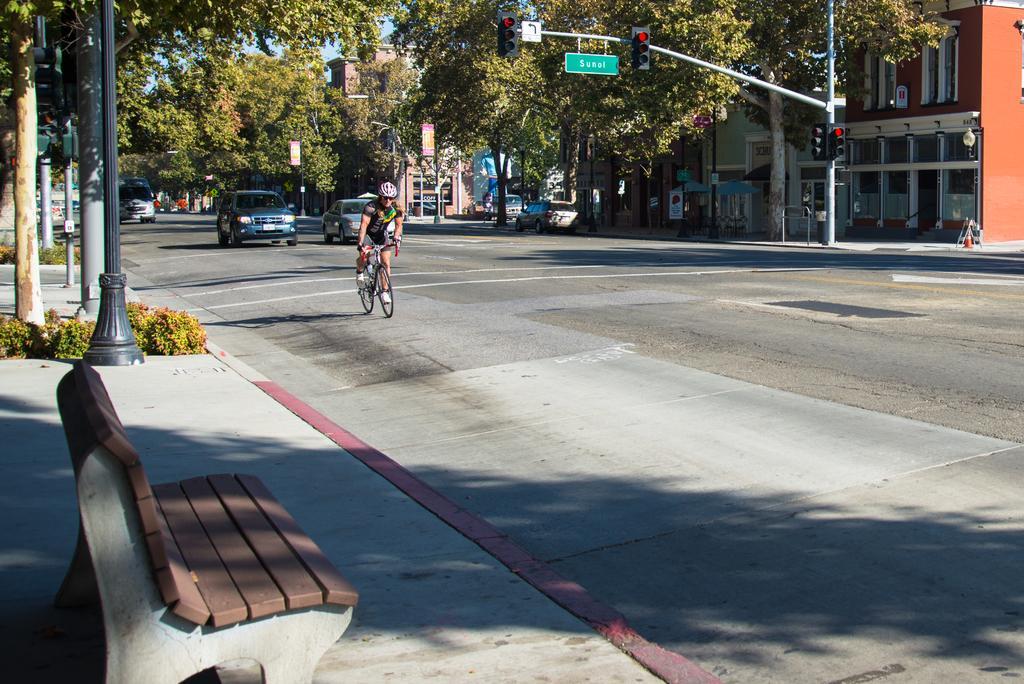In one or two sentences, can you explain what this image depicts? This picture is clicked outside the city. Here, we see women riding bicycle wearing helmet on her head and it is a sunny day. Behind her, we see cars on the road, we even see traffic signals on the left side of the picture. To the left, on the right top of this picture, we can see a building and beside the building, we can see trees. To the left bottom of this picture, we see bench which is placed on the footpath, even shrubs and a pole on the left side of this picture. 